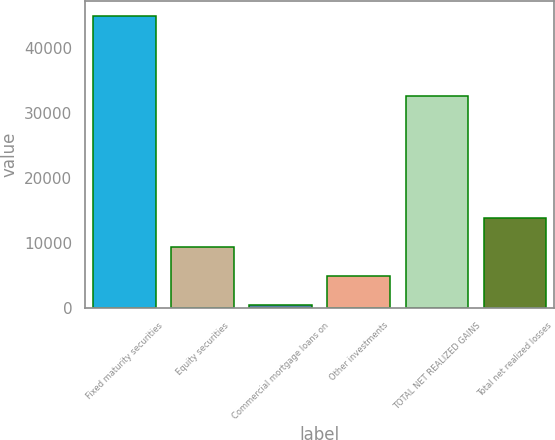<chart> <loc_0><loc_0><loc_500><loc_500><bar_chart><fcel>Fixed maturity securities<fcel>Equity securities<fcel>Commercial mortgage loans on<fcel>Other investments<fcel>TOTAL NET REALIZED GAINS<fcel>Total net realized losses<nl><fcel>44924<fcel>9253.6<fcel>336<fcel>4794.8<fcel>32580<fcel>13712.4<nl></chart> 